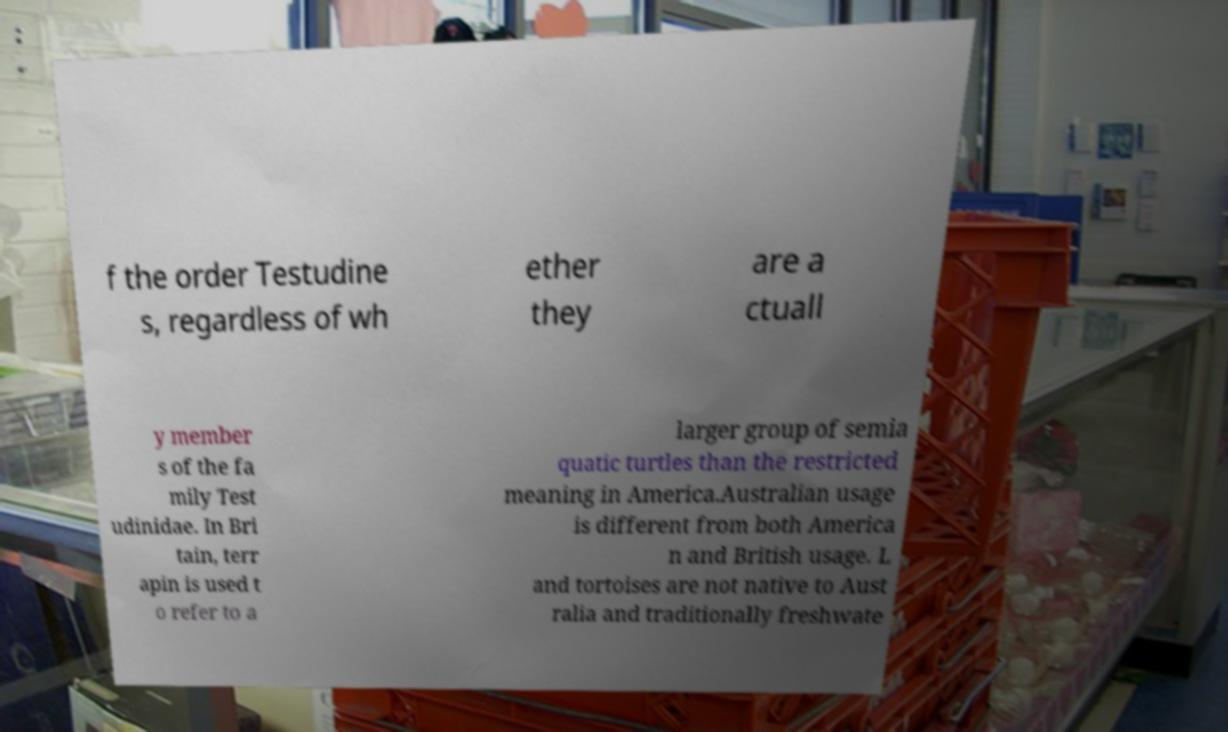Could you assist in decoding the text presented in this image and type it out clearly? f the order Testudine s, regardless of wh ether they are a ctuall y member s of the fa mily Test udinidae. In Bri tain, terr apin is used t o refer to a larger group of semia quatic turtles than the restricted meaning in America.Australian usage is different from both America n and British usage. L and tortoises are not native to Aust ralia and traditionally freshwate 